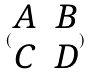<formula> <loc_0><loc_0><loc_500><loc_500>( \begin{matrix} A & B \\ C & D \end{matrix} )</formula> 